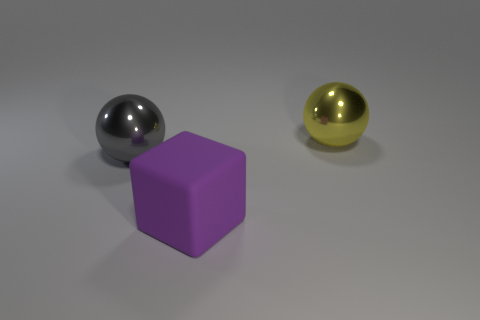The yellow object that is the same material as the gray ball is what size?
Your answer should be very brief. Large. Is the number of large gray balls less than the number of big gray cylinders?
Make the answer very short. No. The object in front of the large ball on the left side of the object behind the gray thing is made of what material?
Provide a short and direct response. Rubber. Is the material of the big ball that is in front of the yellow metal object the same as the object that is on the right side of the large purple rubber object?
Your answer should be compact. Yes. There is a thing that is behind the purple rubber cube and right of the gray metallic sphere; how big is it?
Make the answer very short. Large. There is a purple block that is the same size as the gray ball; what is its material?
Offer a terse response. Rubber. There is a large metallic ball right of the large shiny object in front of the yellow metal object; how many big purple matte objects are on the right side of it?
Provide a short and direct response. 0. Do the big ball on the left side of the big block and the big metallic object that is to the right of the gray metal ball have the same color?
Give a very brief answer. No. What is the color of the big thing that is behind the large rubber block and left of the yellow metal ball?
Offer a terse response. Gray. What number of yellow things have the same size as the gray object?
Offer a very short reply. 1. 